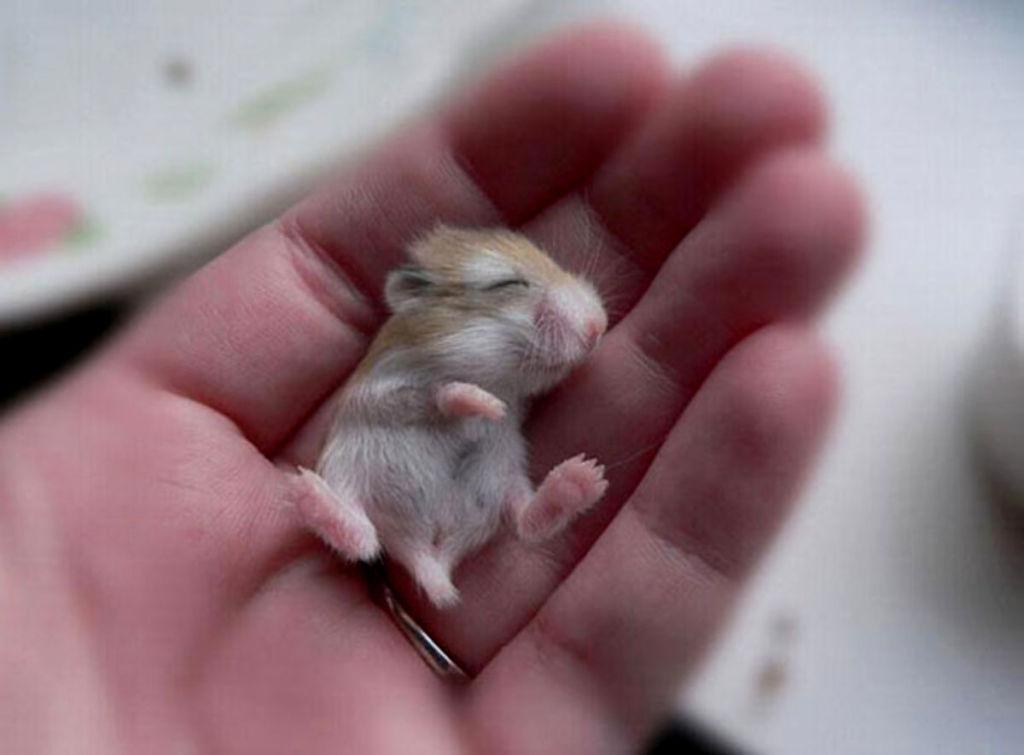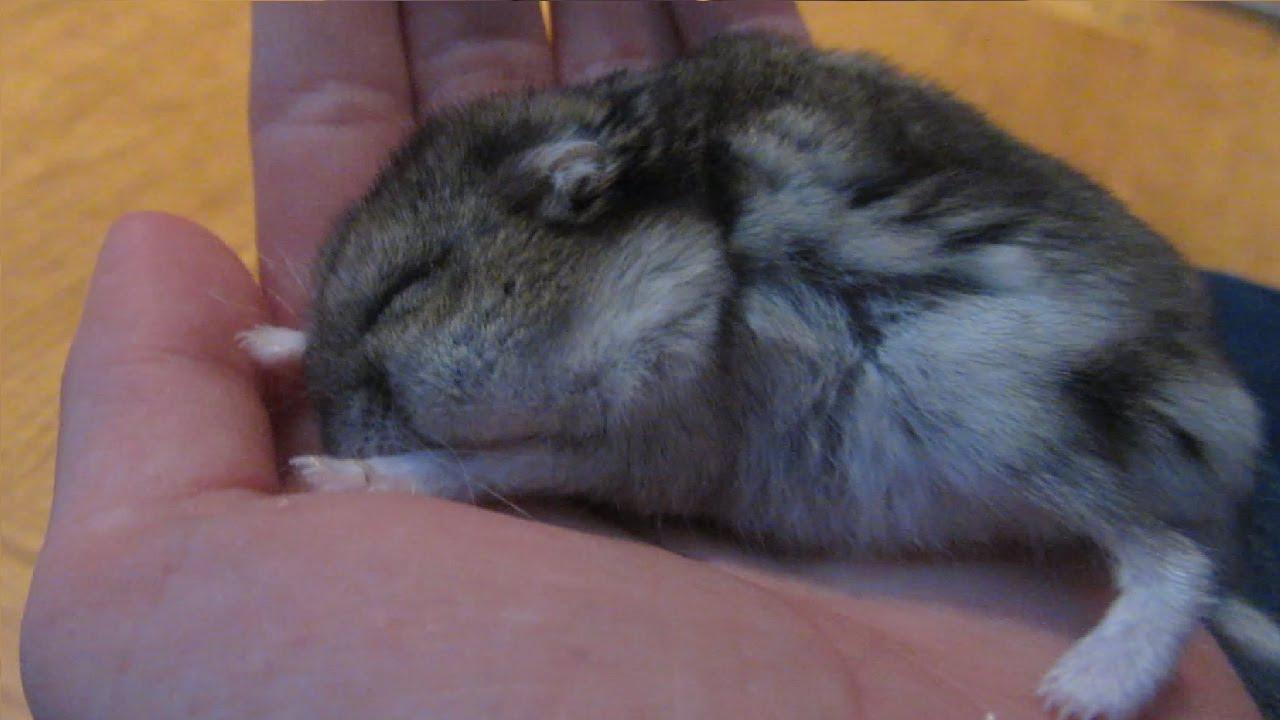The first image is the image on the left, the second image is the image on the right. For the images displayed, is the sentence "Each image shows a hand holding exactly one pet rodent, and each pet rodent is held, but not grasped, in an upturned hand." factually correct? Answer yes or no. Yes. The first image is the image on the left, the second image is the image on the right. Considering the images on both sides, is "The hamsters are all the same color." valid? Answer yes or no. No. 